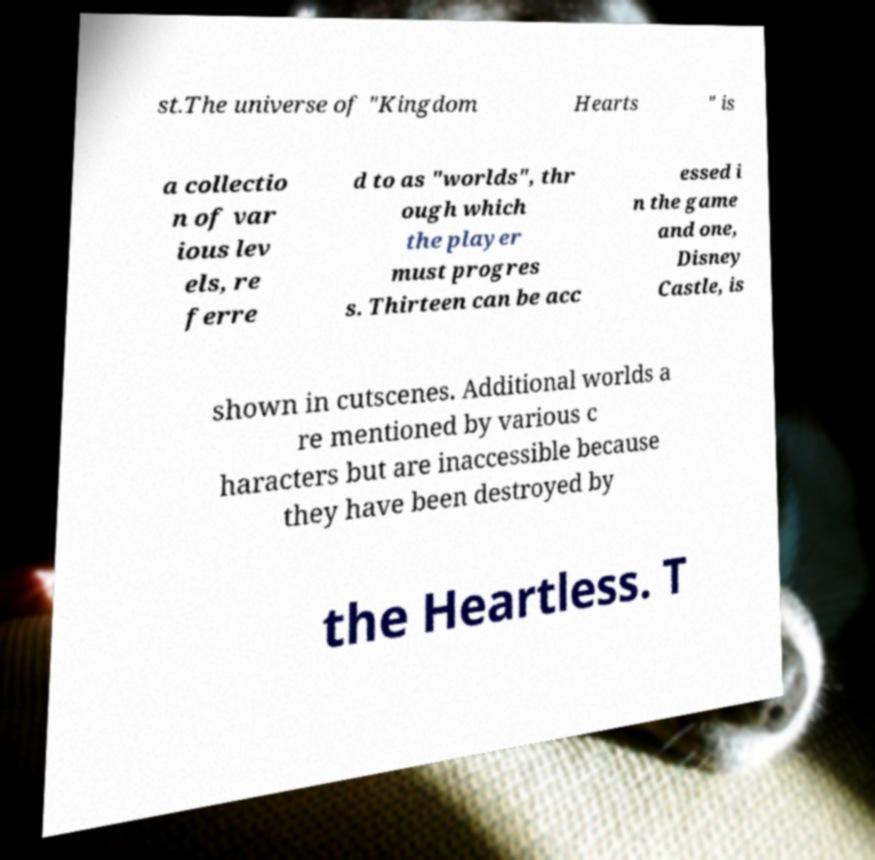Could you extract and type out the text from this image? st.The universe of "Kingdom Hearts " is a collectio n of var ious lev els, re ferre d to as "worlds", thr ough which the player must progres s. Thirteen can be acc essed i n the game and one, Disney Castle, is shown in cutscenes. Additional worlds a re mentioned by various c haracters but are inaccessible because they have been destroyed by the Heartless. T 